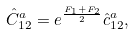<formula> <loc_0><loc_0><loc_500><loc_500>\hat { C } _ { 1 2 } ^ { a } = e ^ { \frac { F _ { 1 } + F _ { 2 } } { 2 } } \hat { c } _ { 1 2 } ^ { a } ,</formula> 